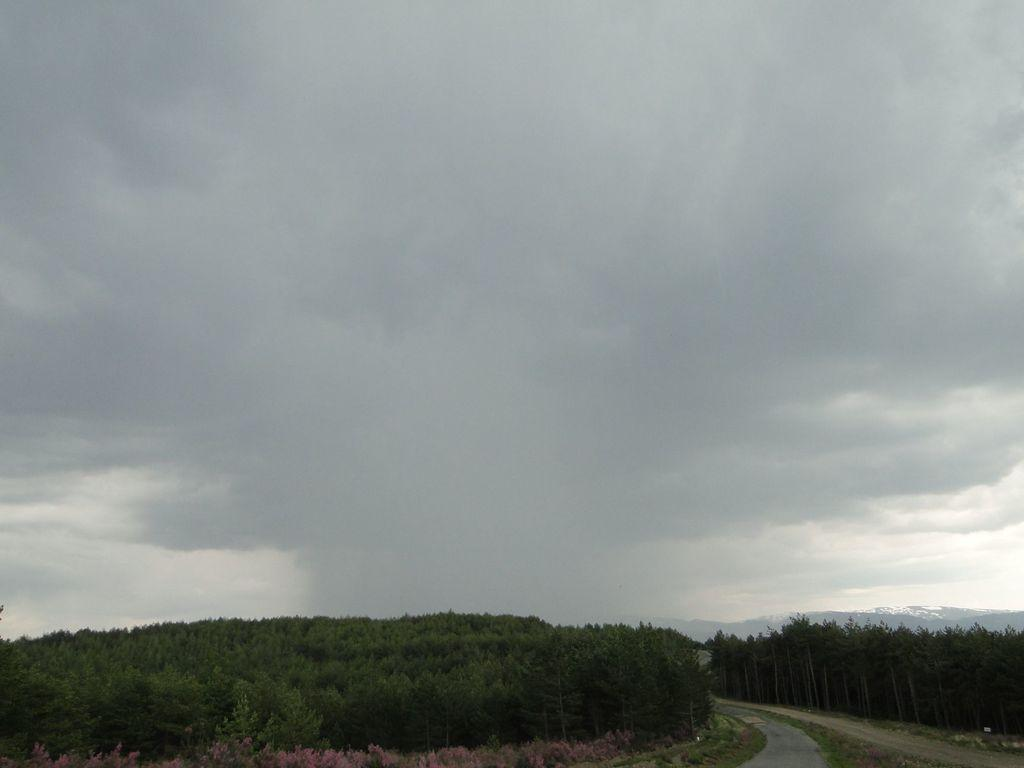What type of vegetation is present at the bottom of the image? There are trees at the bottom of the image. What else can be seen at the bottom of the image? There is a road at the bottom of the image. What is visible in the background of the image? There are hills and the sky visible in the background of the image. What religious symbol can be seen at the top of the hill in the image? There is no religious symbol present at the top of the hill in the image. What effect does the girl have on the trees at the bottom of the image? There is no girl present in the image, so no effect can be observed on the trees. 